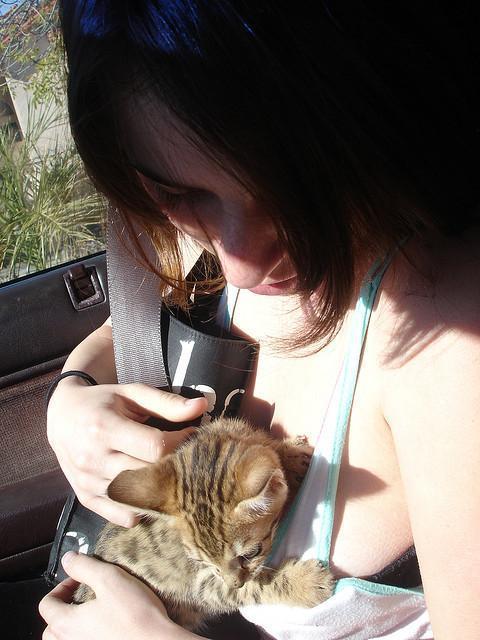How many elephants are in the picture?
Give a very brief answer. 0. 